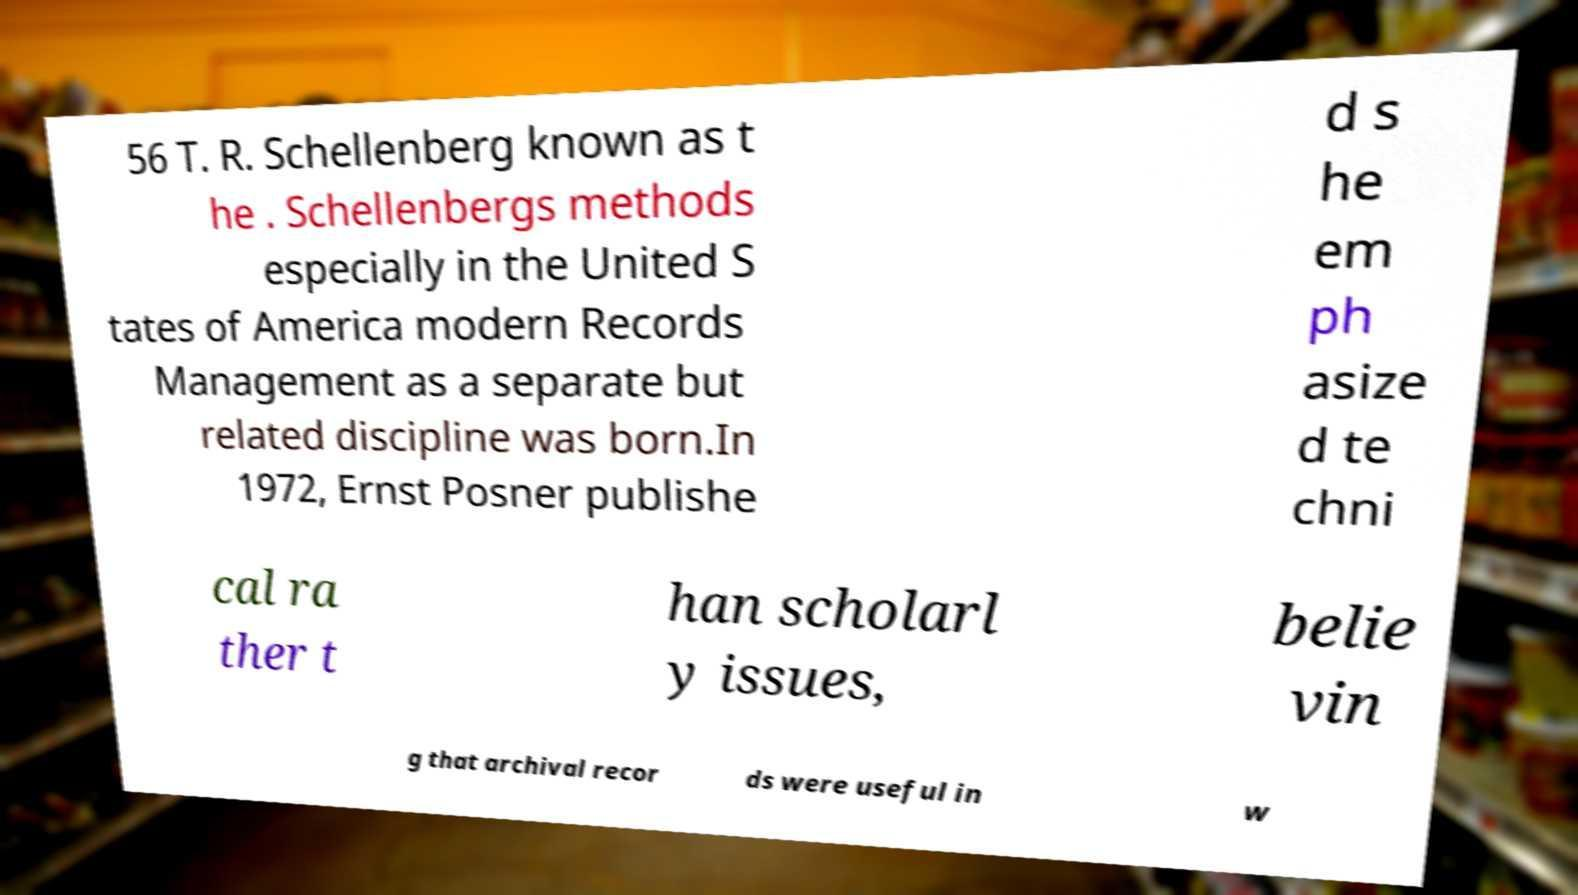Could you assist in decoding the text presented in this image and type it out clearly? 56 T. R. Schellenberg known as t he . Schellenbergs methods especially in the United S tates of America modern Records Management as a separate but related discipline was born.In 1972, Ernst Posner publishe d s he em ph asize d te chni cal ra ther t han scholarl y issues, belie vin g that archival recor ds were useful in w 